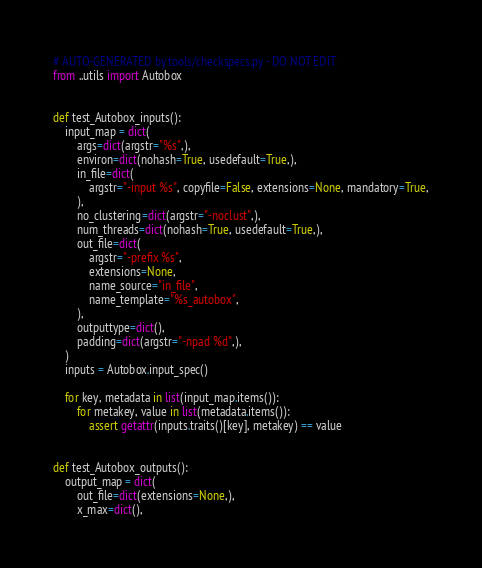<code> <loc_0><loc_0><loc_500><loc_500><_Python_># AUTO-GENERATED by tools/checkspecs.py - DO NOT EDIT
from ..utils import Autobox


def test_Autobox_inputs():
    input_map = dict(
        args=dict(argstr="%s",),
        environ=dict(nohash=True, usedefault=True,),
        in_file=dict(
            argstr="-input %s", copyfile=False, extensions=None, mandatory=True,
        ),
        no_clustering=dict(argstr="-noclust",),
        num_threads=dict(nohash=True, usedefault=True,),
        out_file=dict(
            argstr="-prefix %s",
            extensions=None,
            name_source="in_file",
            name_template="%s_autobox",
        ),
        outputtype=dict(),
        padding=dict(argstr="-npad %d",),
    )
    inputs = Autobox.input_spec()

    for key, metadata in list(input_map.items()):
        for metakey, value in list(metadata.items()):
            assert getattr(inputs.traits()[key], metakey) == value


def test_Autobox_outputs():
    output_map = dict(
        out_file=dict(extensions=None,),
        x_max=dict(),</code> 